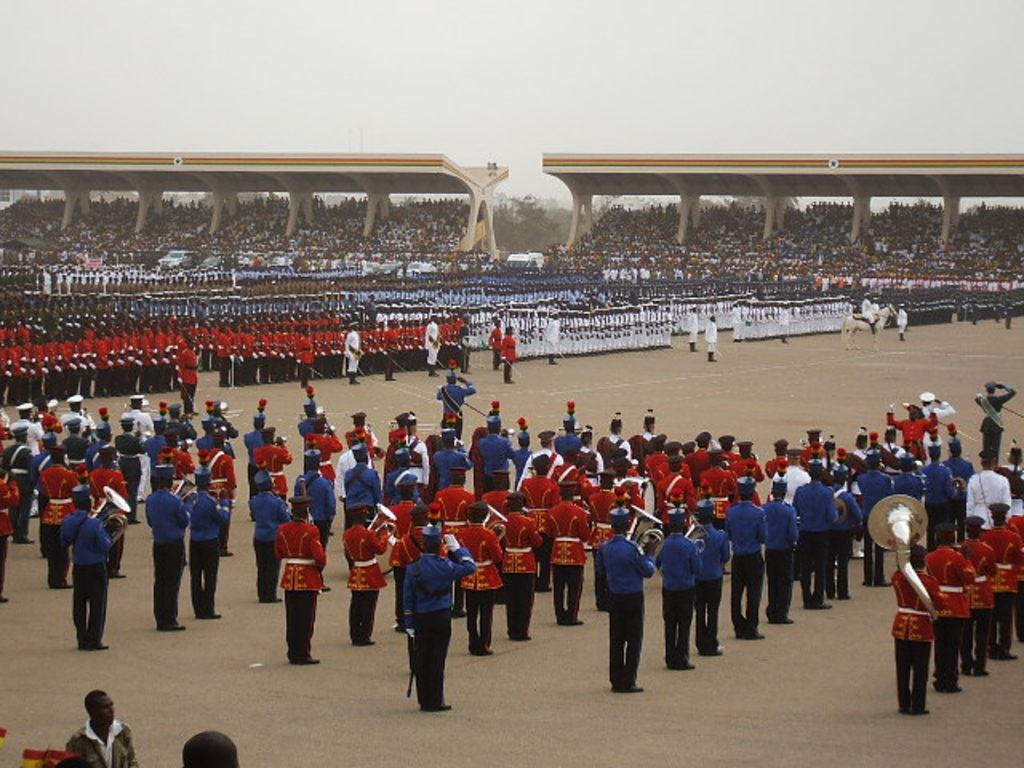In one or two sentences, can you explain what this image depicts? In front of the image there are people standing and there are holding some objects. There is a person sitting on the horse. In the background of the image there are a few people under the rooftops. There are pillars. There are trees. At the top of the image there is sky. 